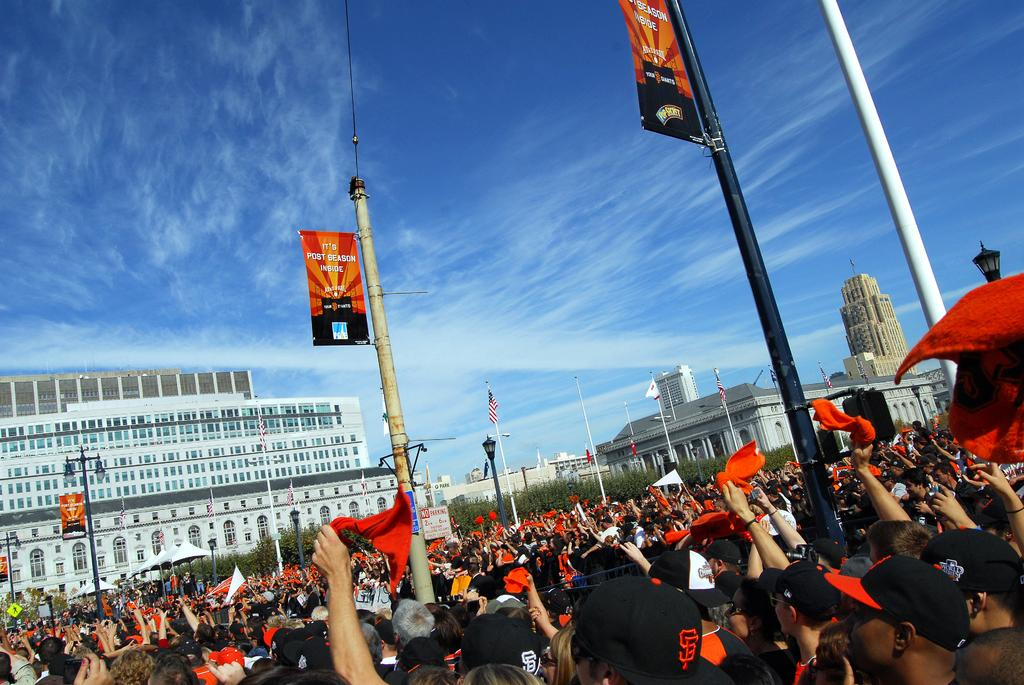What can be seen at the bottom of the image? There are persons at the bottom of the image. What objects are present in the image that are used for support or structure? There are poles in the image. What type of vegetation is visible in the image? There are trees in the image. What type of man-made structures can be seen in the image? There are buildings on the ground in the image. What is visible in the background of the image? There are clouds and a blue sky in the background of the image. What is the temperature of the current afternoon in the image? The provided facts do not mention the temperature or the time of day, so it is impossible to determine the temperature or whether it is afternoon in the image. 